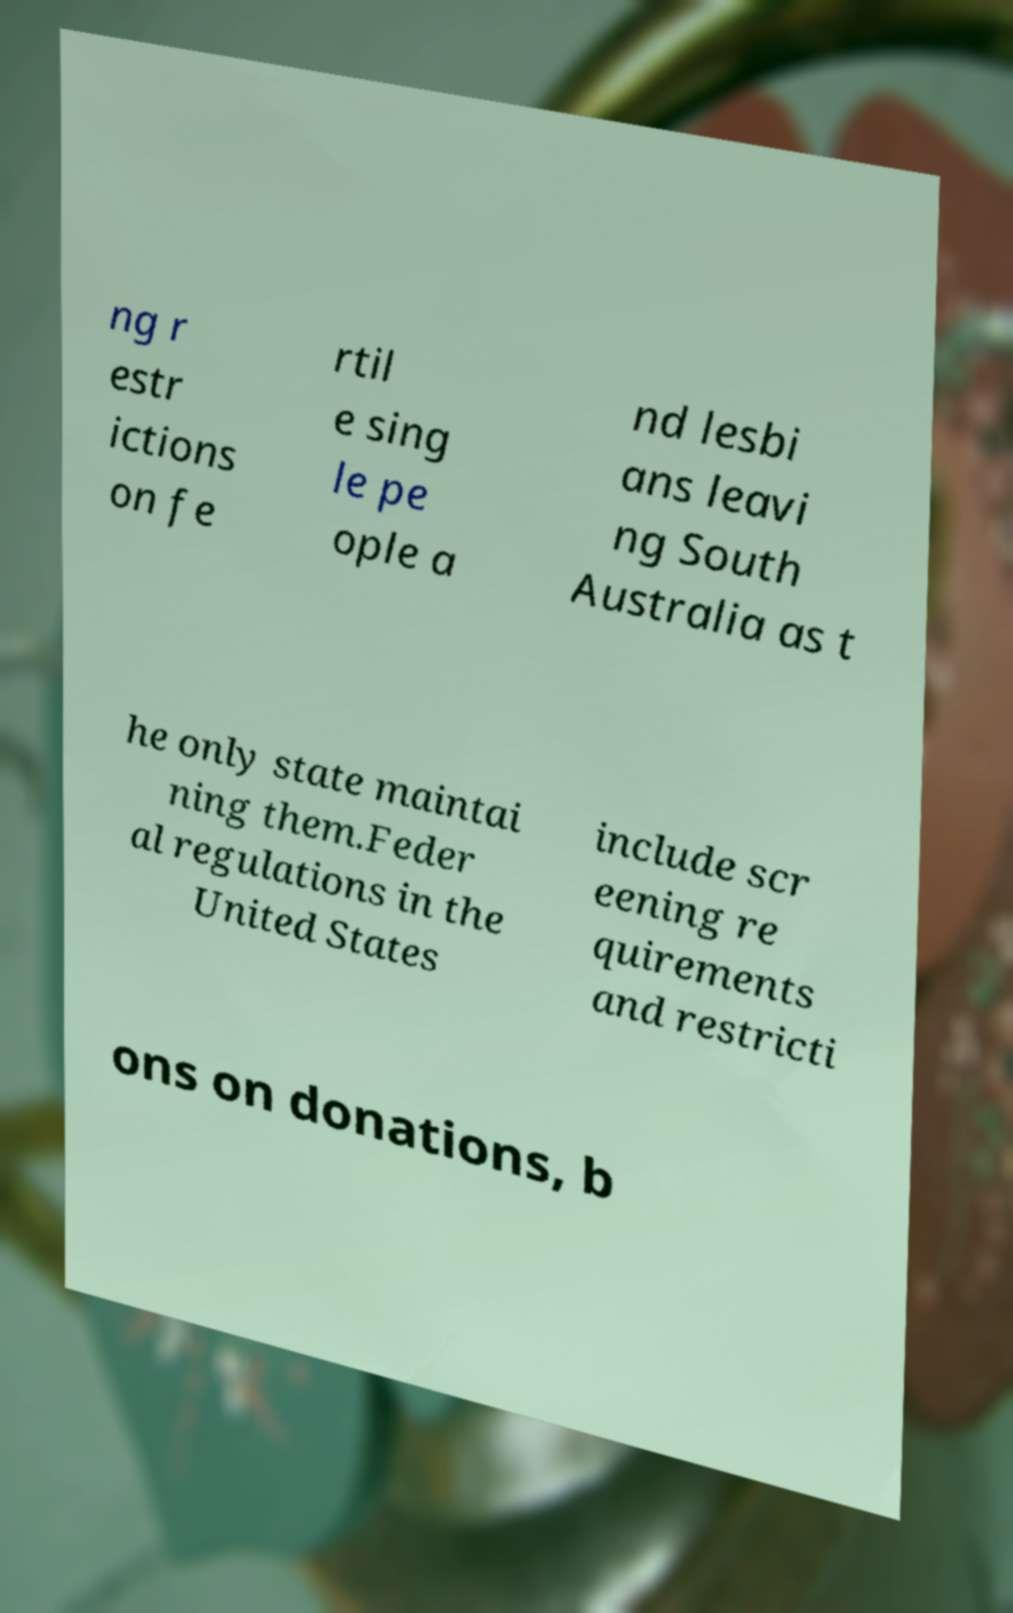Could you assist in decoding the text presented in this image and type it out clearly? ng r estr ictions on fe rtil e sing le pe ople a nd lesbi ans leavi ng South Australia as t he only state maintai ning them.Feder al regulations in the United States include scr eening re quirements and restricti ons on donations, b 